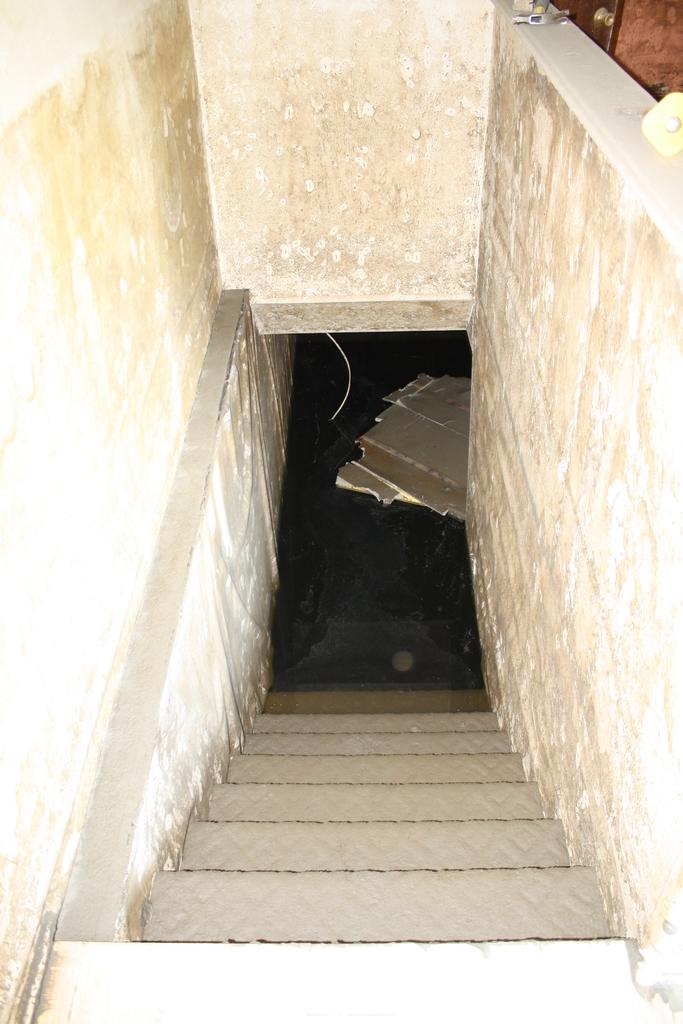What can be seen in the foreground of the image? There are stairs in the foreground of the image. What surrounds the stairs in the image? There is a wall on either side of the stairs. What type of material is used for the objects visible in the image? The wooden plank-like objects suggest that they are made of wood. What type of flag is visible on the wooden plank-like objects in the image? There is no flag visible on the wooden plank-like objects in the image. 